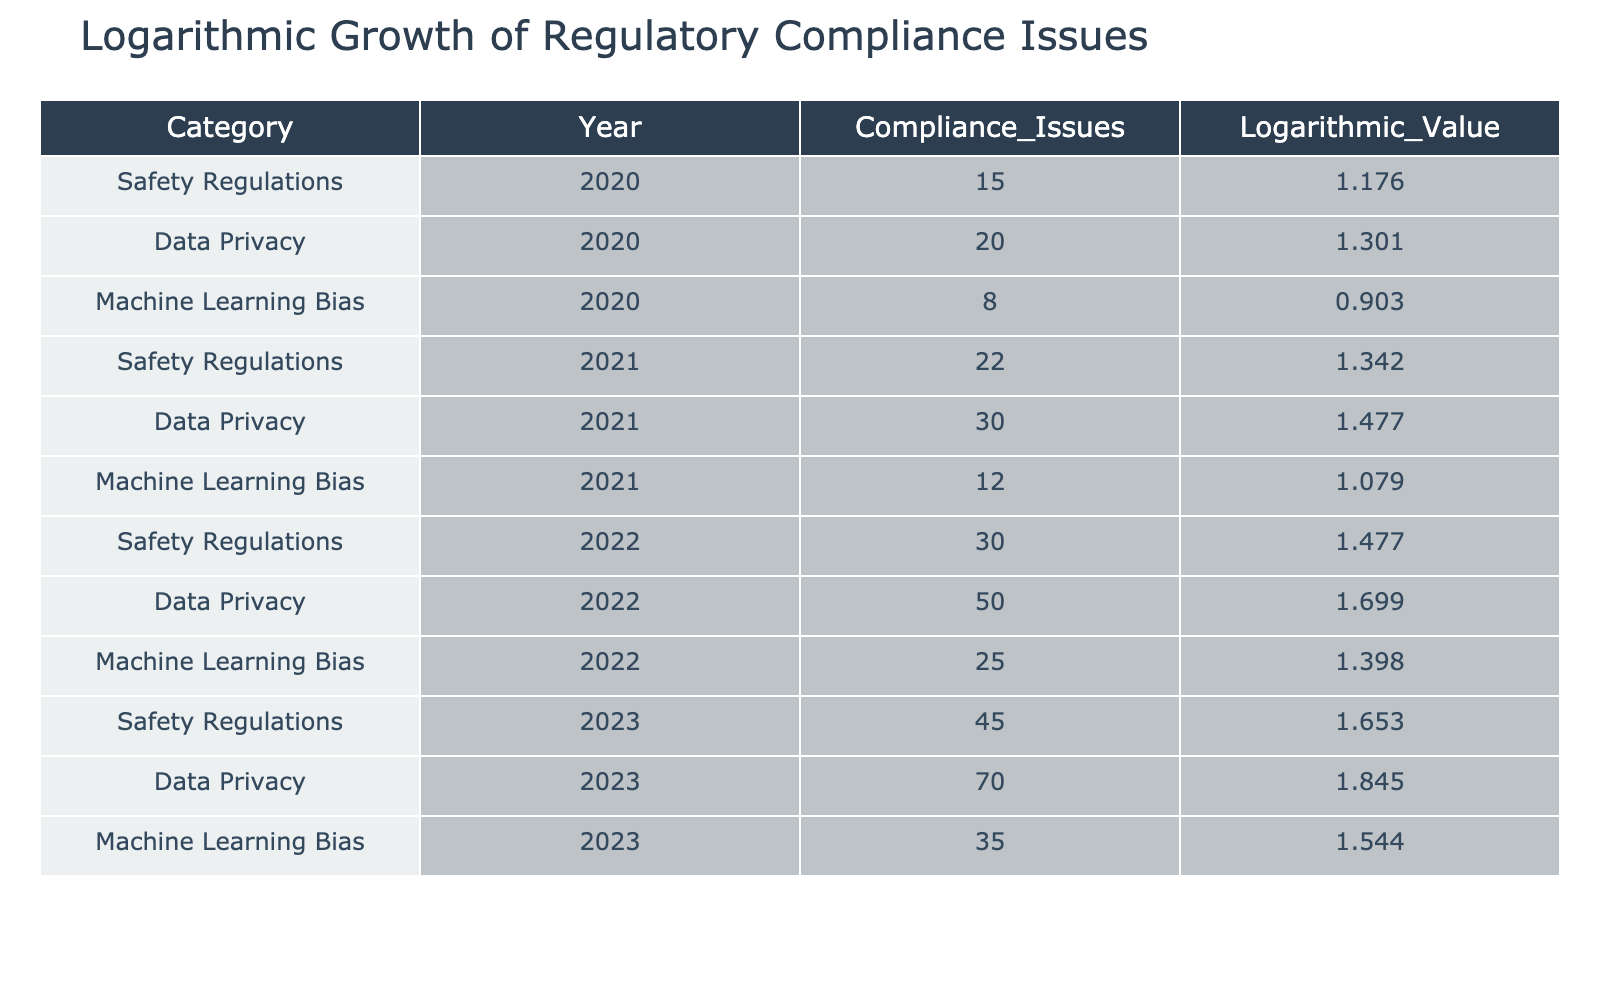What is the highest number of compliance issues recorded in a single year? The highest number of compliance issues is found in the Data Privacy category for the year 2023, which has 70 issues. I looked through the 'Compliance_Issues' column and found that 70 is the maximum value across all entries.
Answer: 70 What was the logarithmic value of compliance issues for Machine Learning Bias in 2022? In the table, the logarithmic value for Machine Learning Bias in 2022 is 1.398. I found the 2022 row for Machine Learning Bias and then noted the corresponding logarithmic value.
Answer: 1.398 In which year did Safety Regulations see the largest increase in compliance issues from the previous year? To find the largest increase for Safety Regulations, I checked the compliance issues for each year: in 2021, it increased from 15 (2020) to 22, and in 2022, it increased from 22 to 30. The largest increase was from 2022 to 2023, increasing from 30 to 45, resulting in a 15 issue increase.
Answer: 2023 Is the number of compliance issues for Data Privacy in 2021 more than those in Machine Learning Bias for the same year? Yes, Data Privacy had 30 compliance issues in 2021, while Machine Learning Bias had 12 compliance issues in that year, making it true that Data Privacy's issues exceed Machine Learning Bias’s.
Answer: Yes What is the sum of the compliance issues for all categories in 2020? To find the sum for 2020, I added the compliance issues: 15 (Safety Regulations) + 20 (Data Privacy) + 8 (Machine Learning Bias) = 43. Summing these values together leads to the total for that year.
Answer: 43 What was the overall trend in logarithmic values for Machine Learning Bias from 2020 to 2023? The logarithmic values for Machine Learning Bias are: 0.903 (2020), 1.079 (2021), 1.398 (2022), and 1.544 (2023). Observing these values, there is a clear upward trend over the years, indicating increasing compliance issues.
Answer: Increasing Is there a year where both Data Privacy and Machine Learning Bias had more compliance issues than Safety Regulations? No, in all years listed, Safety Regulations always had a higher or equal number of compliance issues compared to Data Privacy and Machine Learning Bias when checking their respective values for each year.
Answer: No What is the average number of compliance issues for Data Privacy across all years? The total compliance issues for Data Privacy are 20 (2020) + 30 (2021) + 50 (2022) + 70 (2023) = 170. There are 4 years, so the average is 170 / 4 = 42.5. The average was deduced by calculating the total and dividing by the number of years.
Answer: 42.5 Which category had the highest logarithmic value in 2023? In the table, Data Privacy in 2023 has the highest logarithmic value of 1.845, making it the category with the highest logarithmic value for that year.
Answer: 1.845 